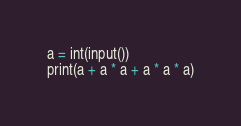<code> <loc_0><loc_0><loc_500><loc_500><_Python_>a = int(input())
print(a + a * a + a * a * a)</code> 